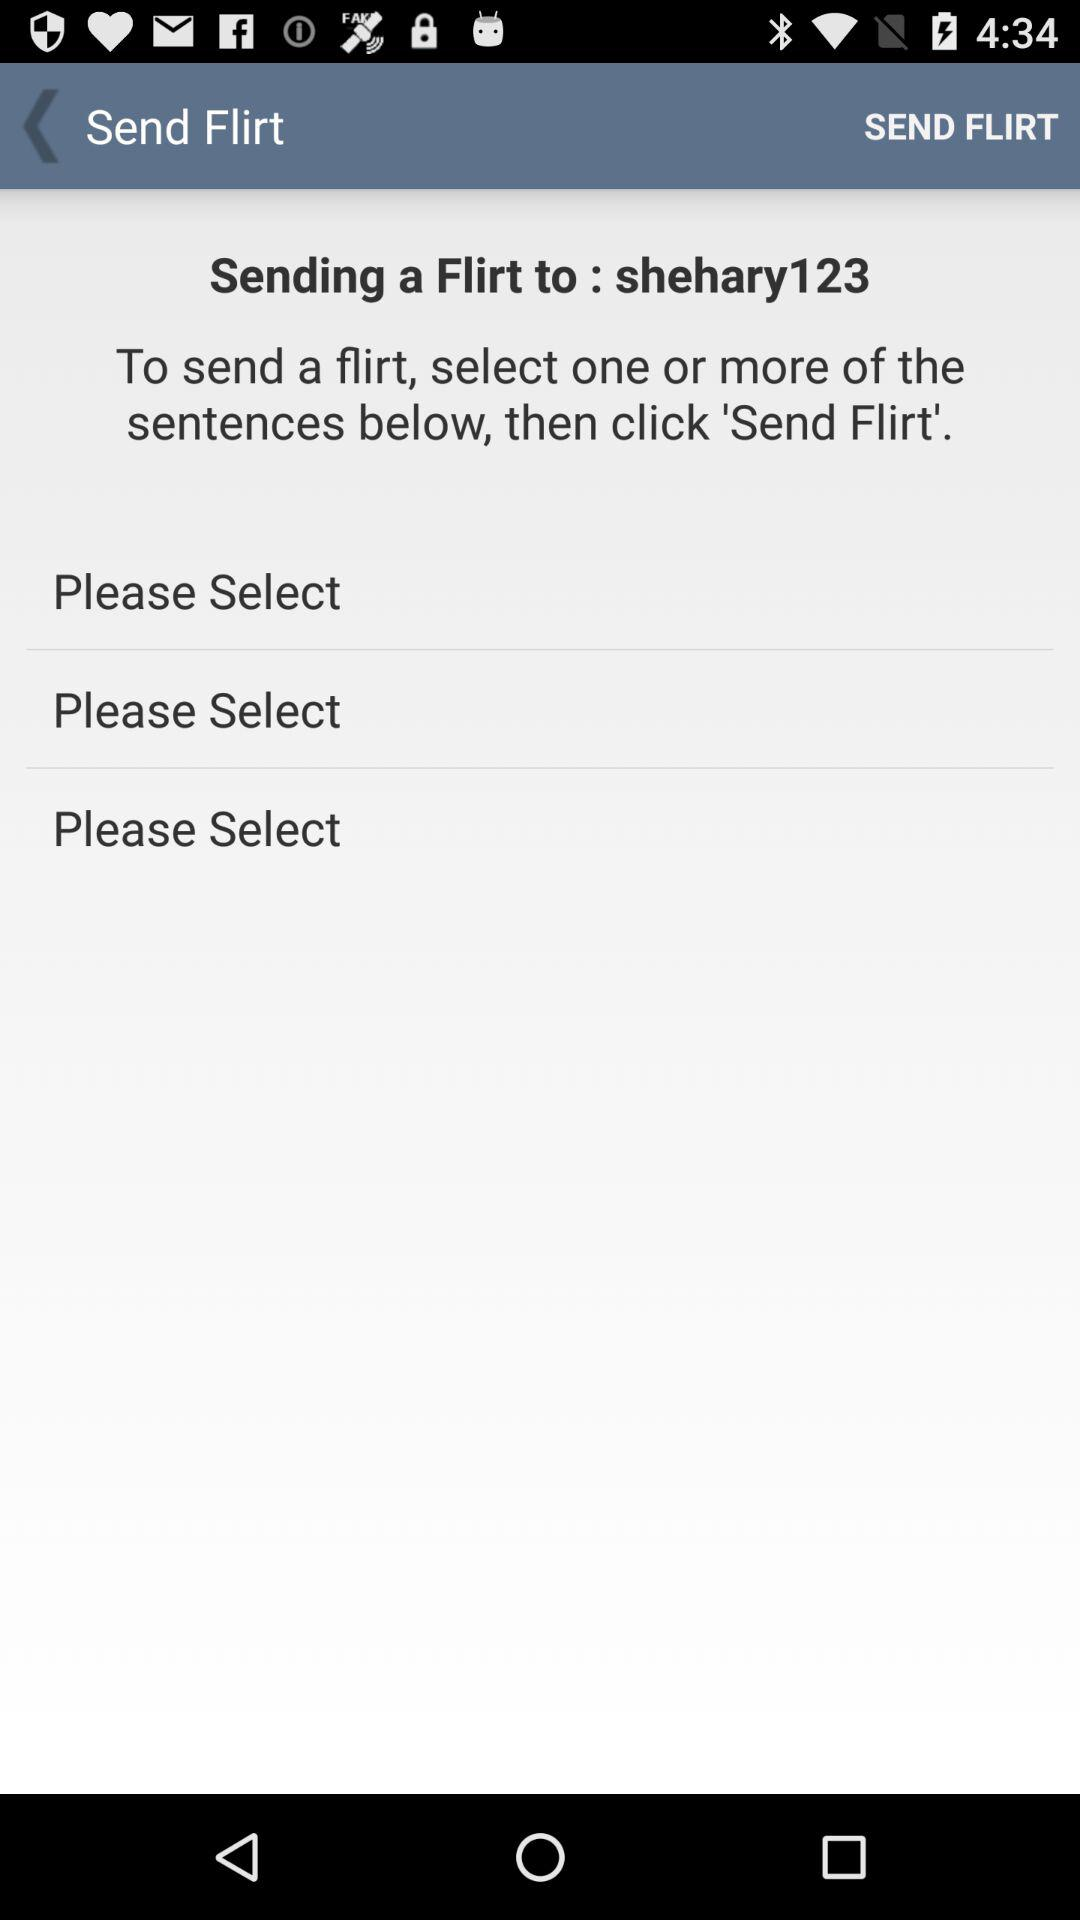What is the name of the user? The name of the user is "shehary123". 